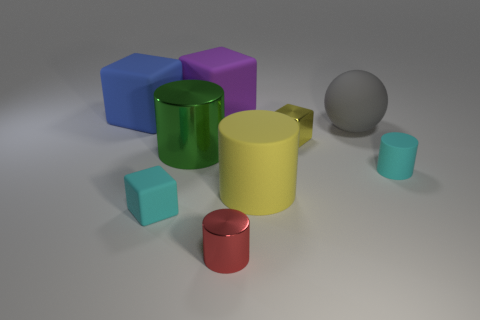There is a purple block that is the same size as the green shiny cylinder; what material is it?
Provide a succinct answer. Rubber. What number of other things are there of the same material as the purple thing
Offer a terse response. 5. What is the color of the tiny thing that is behind the yellow matte thing and left of the big gray ball?
Make the answer very short. Yellow. What number of objects are either big rubber objects behind the small matte cylinder or large brown spheres?
Keep it short and to the point. 3. What number of other things are the same color as the small metallic block?
Your answer should be very brief. 1. Are there the same number of green shiny things that are in front of the large purple rubber cube and small yellow matte blocks?
Your answer should be compact. No. There is a metal cylinder that is to the right of the large object that is behind the large blue matte block; how many shiny objects are right of it?
Provide a short and direct response. 1. Is there anything else that is the same size as the blue block?
Offer a terse response. Yes. Does the red object have the same size as the cyan object that is behind the yellow matte object?
Keep it short and to the point. Yes. What number of tiny cyan things are there?
Your answer should be compact. 2. 